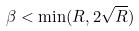<formula> <loc_0><loc_0><loc_500><loc_500>\beta < \min ( R , 2 \sqrt { R } )</formula> 